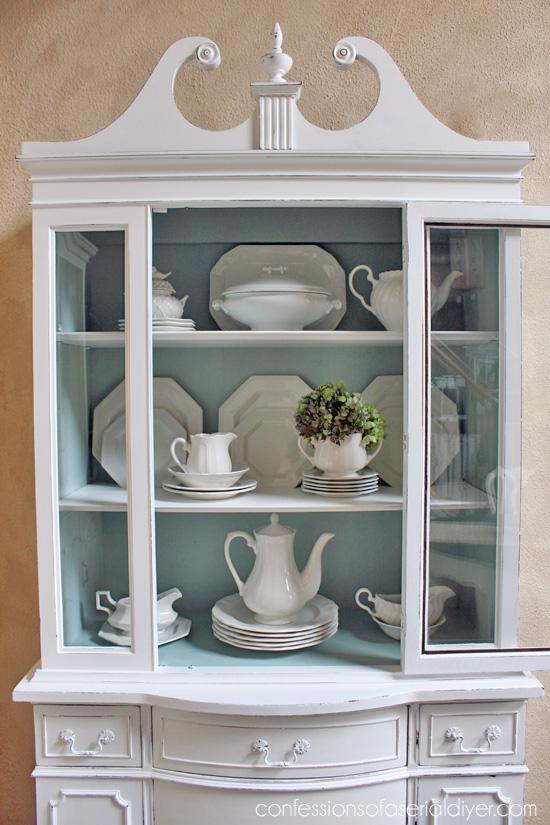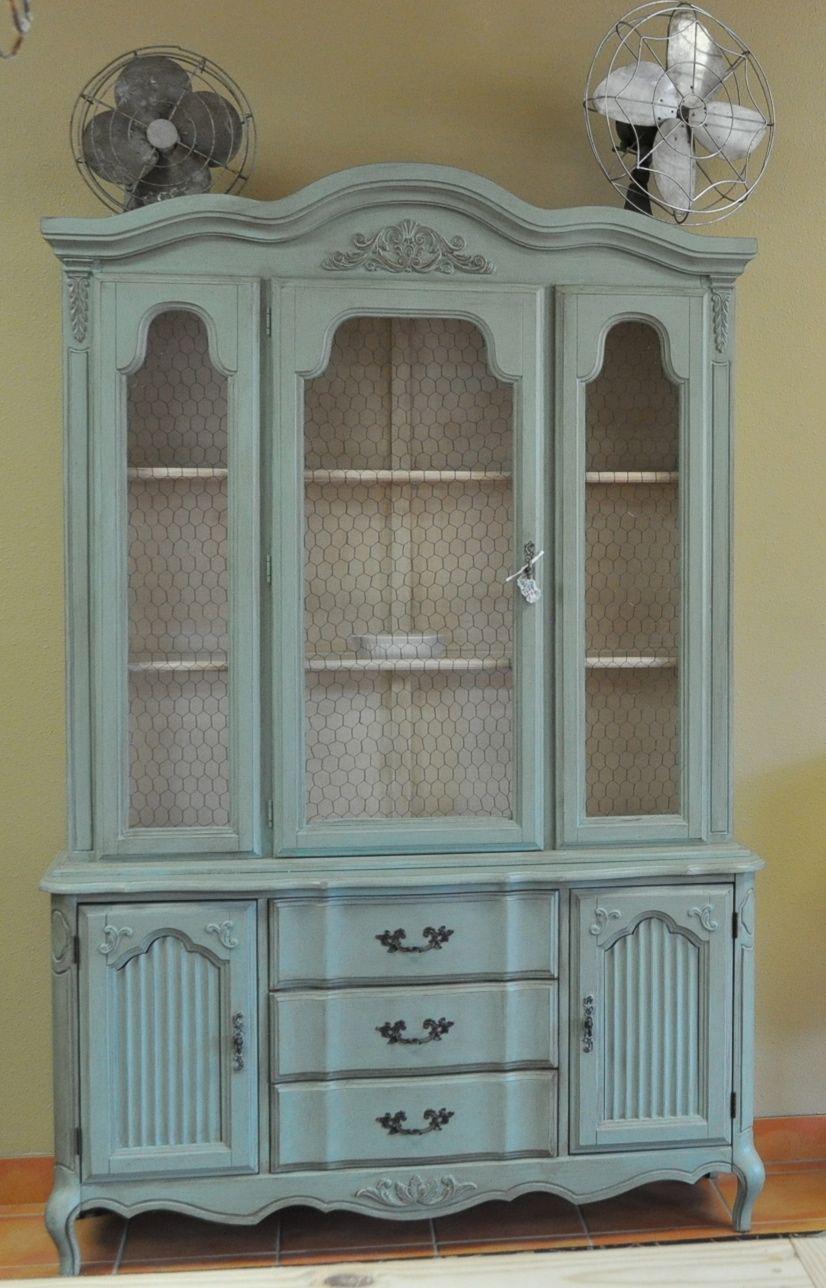The first image is the image on the left, the second image is the image on the right. For the images displayed, is the sentence "Both cabinets are filled with crockery." factually correct? Answer yes or no. No. The first image is the image on the left, the second image is the image on the right. Analyze the images presented: Is the assertion "The right image contains a turquoise wooden cabinet." valid? Answer yes or no. Yes. 